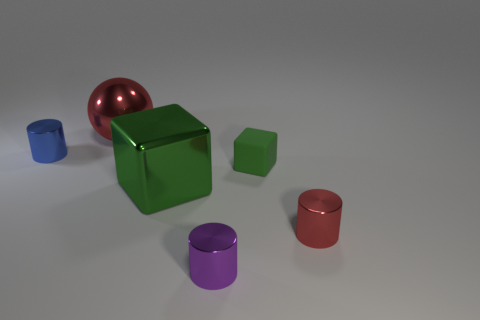What number of other tiny things are the same shape as the tiny blue metallic thing?
Offer a very short reply. 2. Is the number of purple metal objects that are behind the rubber block less than the number of cubes to the right of the red metallic cylinder?
Provide a short and direct response. No. What number of blocks are behind the cylinder that is behind the red shiny cylinder?
Give a very brief answer. 0. Are there any cyan metal cylinders?
Keep it short and to the point. No. Is there a tiny green block made of the same material as the blue object?
Provide a succinct answer. No. Are there more big green things that are on the left side of the large red metal sphere than tiny shiny things to the left of the big metal cube?
Provide a succinct answer. No. Is the size of the red metallic sphere the same as the blue shiny cylinder?
Offer a very short reply. No. There is a small cylinder left of the red object that is behind the blue shiny cylinder; what color is it?
Ensure brevity in your answer.  Blue. The metallic block has what color?
Keep it short and to the point. Green. Is there another tiny thing that has the same color as the matte object?
Your answer should be very brief. No. 